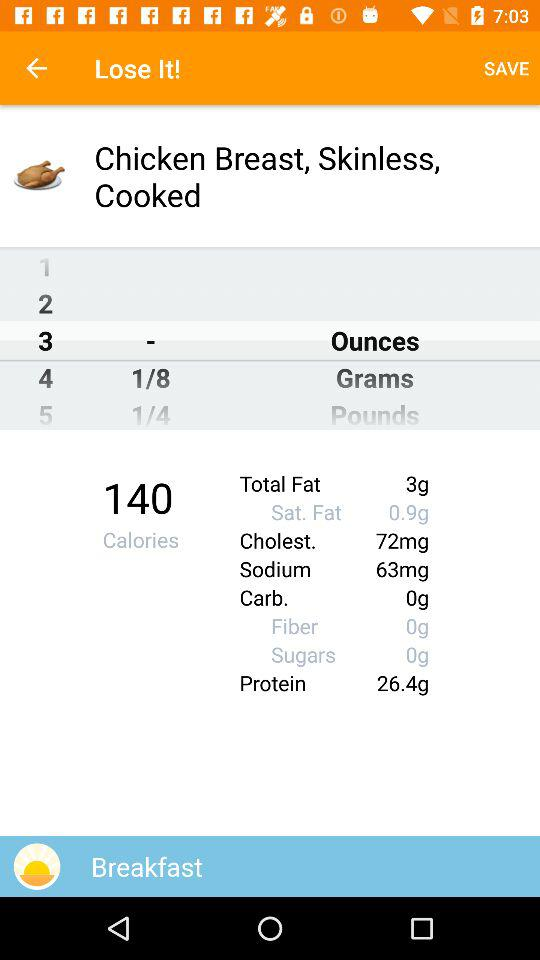How many grams of protein does the chicken breast contain?
Answer the question using a single word or phrase. 26.4g 